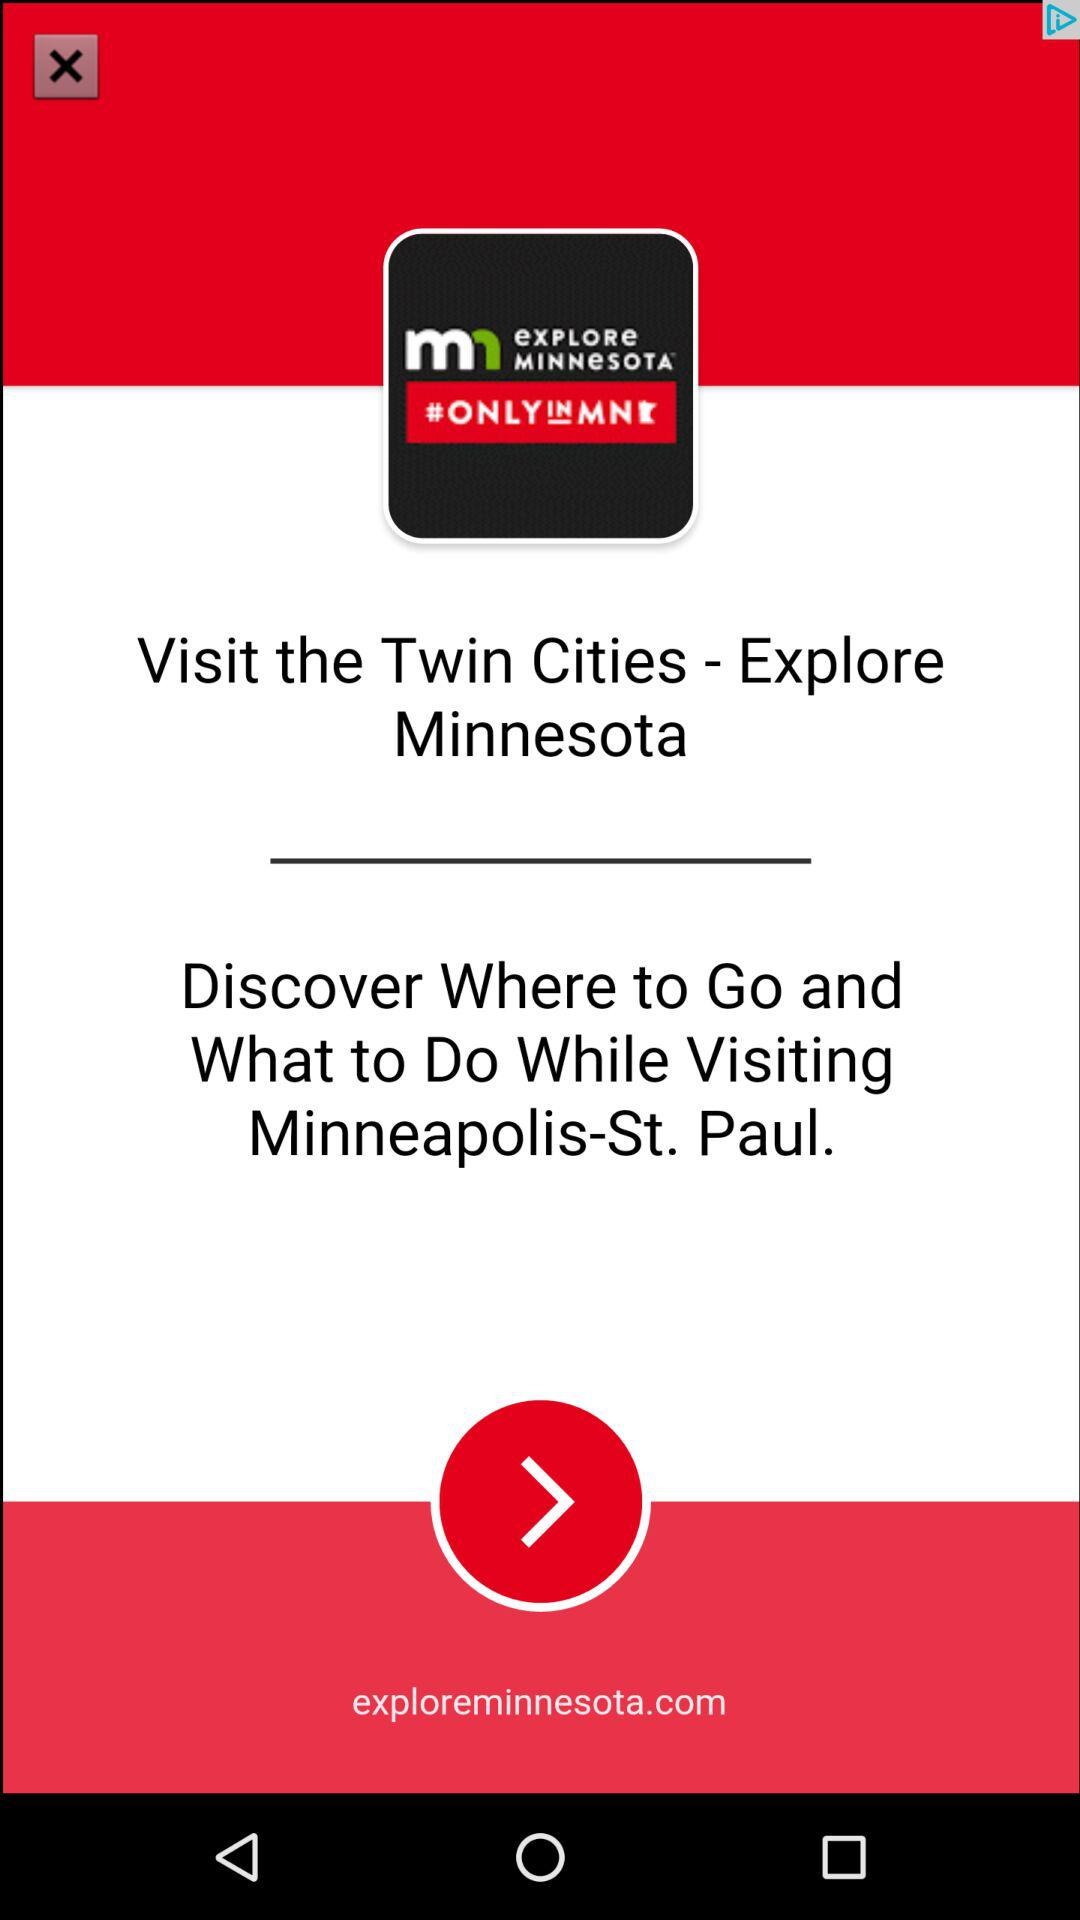Where can I visit this app?
When the provided information is insufficient, respond with <no answer>. <no answer> 